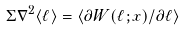Convert formula to latex. <formula><loc_0><loc_0><loc_500><loc_500>\Sigma \nabla ^ { 2 } \langle \ell \rangle = \left \langle \partial W ( \ell ; { x } ) / \partial \ell \right \rangle</formula> 